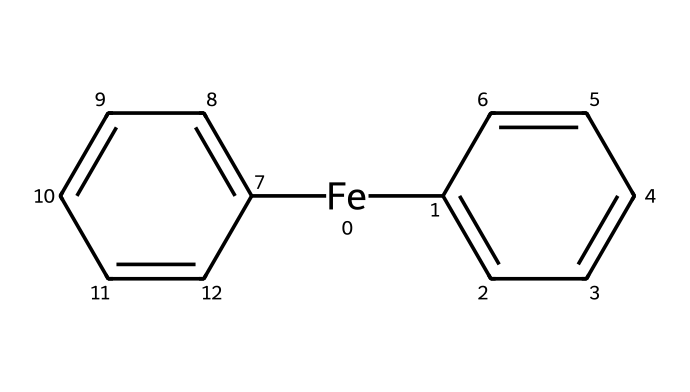What is the central metal in ferrocene? The SMILES notation indicates an iron atom ([Fe]), identifying it as the central metal of ferrocene.
Answer: iron How many carbons are present in the structure of ferrocene? The structure contains two cyclopentadienyl rings, each contributing five carbon atoms, totaling ten carbon atoms.
Answer: ten What type of bonding occurs between the iron atom and the cyclopentadienyl rings? The structure shows the iron bonded to two cyclopentadienyl anions through coordinate covalent bonds, characteristic of organometallic compounds.
Answer: coordinate covalent bonds What is the total number of hydrogen atoms in ferrocene? Each cyclopentadienyl ring has four hydrogen atoms due to the bonding with iron, adding up to a total of eight hydrogen atoms in the entire structure.
Answer: eight What is the hybridization of the iron atom in ferrocene? The iron in ferrocene is typically considered to be in an approximate sp2 hybridization state, allowing for the planar arrangement of the cyclopentadienyl rings.
Answer: sp2 How does the structure of ferrocene contribute to its stability? The sandwich structure, with the central iron atom between two cyclopentadienyl ligands, allows for delocalization of electrons, providing additional stability through resonance.
Answer: resonance stability 